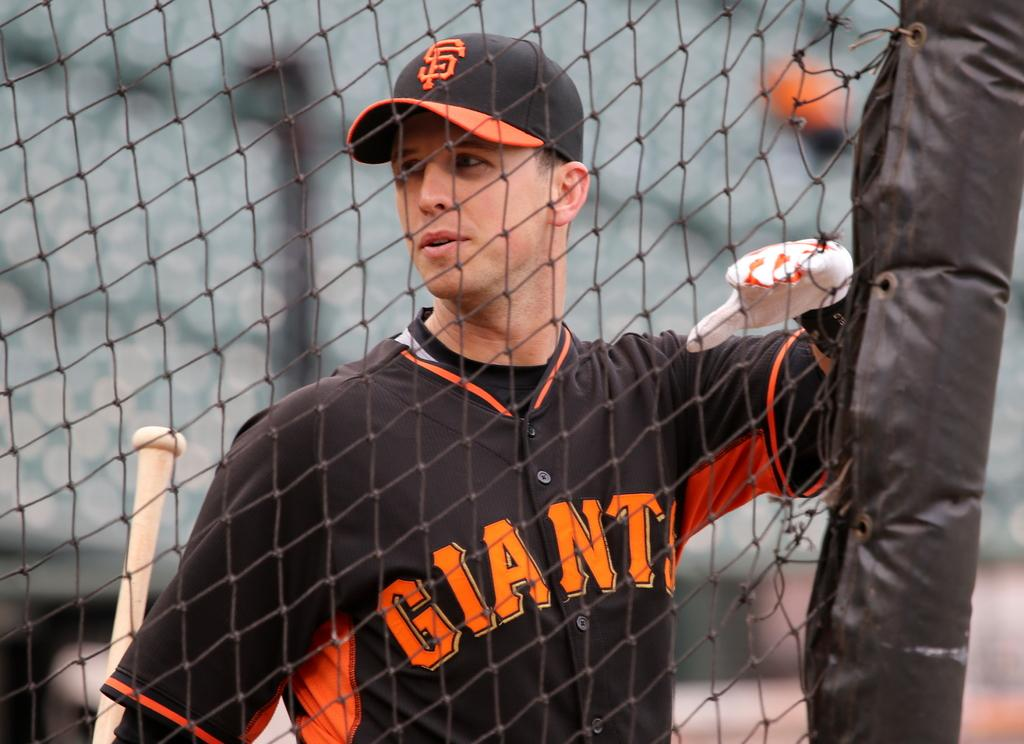<image>
Share a concise interpretation of the image provided. A baseball player for the Giants wears a uniform that is black and orange. 